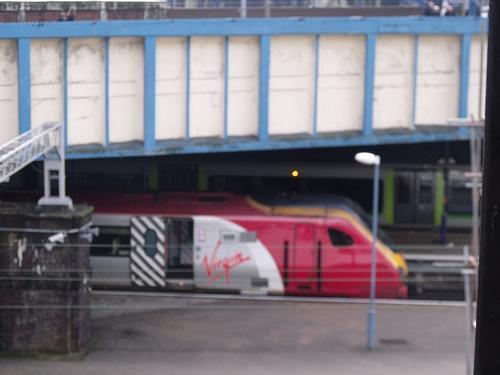How many dogs are in the photo?
Give a very brief answer. 0. How many trains are there?
Give a very brief answer. 2. 